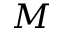<formula> <loc_0><loc_0><loc_500><loc_500>M</formula> 